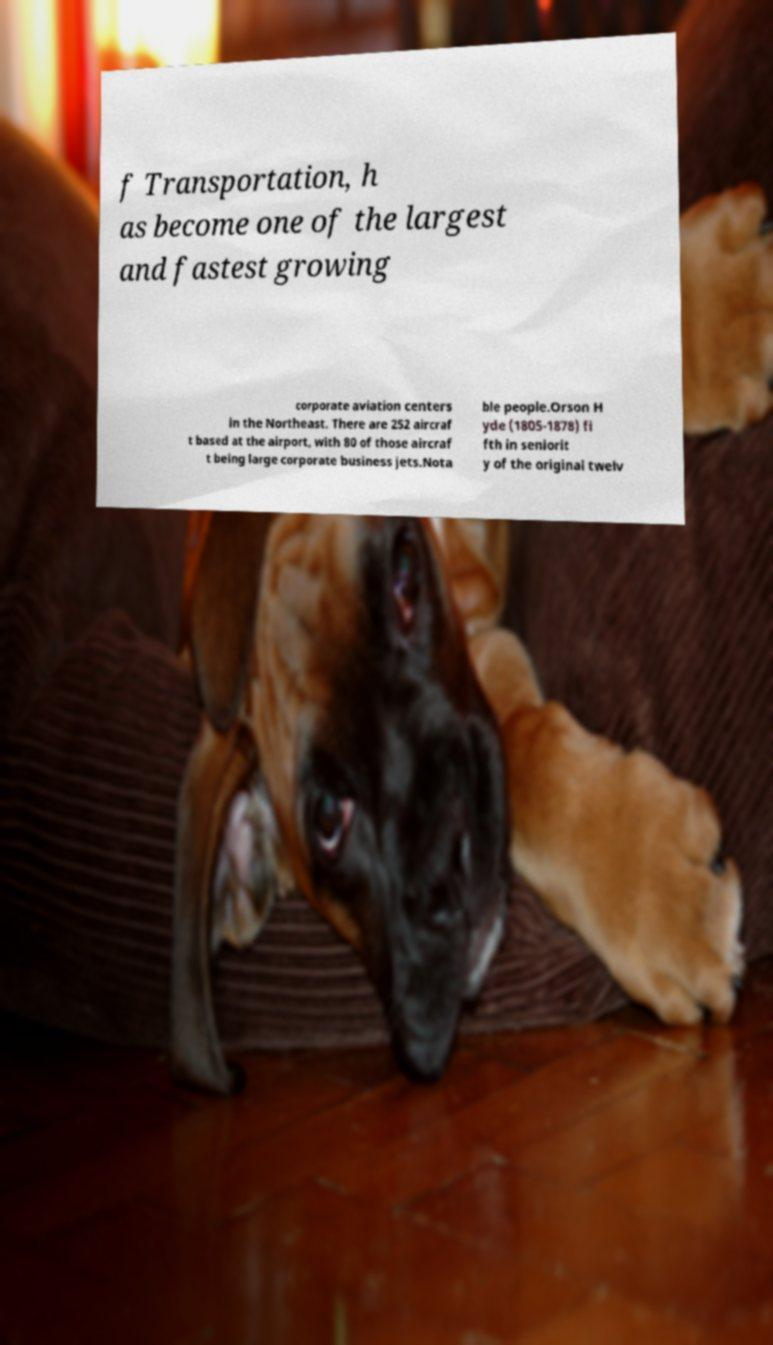For documentation purposes, I need the text within this image transcribed. Could you provide that? f Transportation, h as become one of the largest and fastest growing corporate aviation centers in the Northeast. There are 252 aircraf t based at the airport, with 80 of those aircraf t being large corporate business jets.Nota ble people.Orson H yde (1805-1878) fi fth in seniorit y of the original twelv 